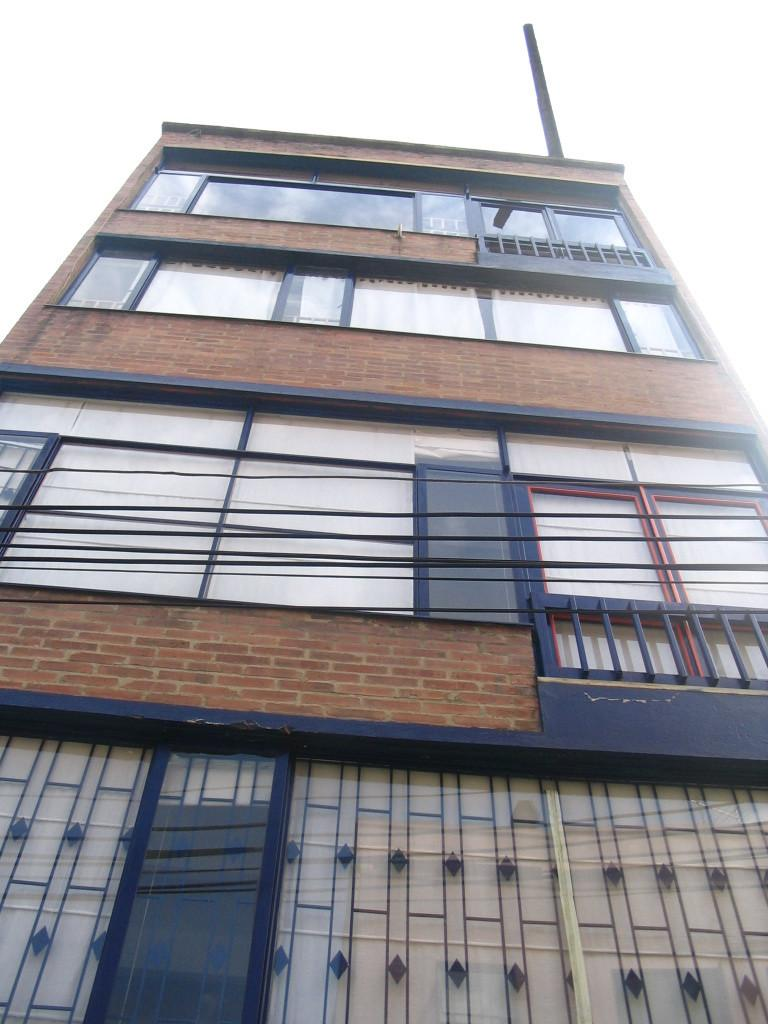What is the main structure in the image? There is a big building in the image. What material is used for some parts of the building? The building has glass elements, such as windows or walls. How much lettuce can be seen growing on the building in the image? There is no lettuce present on the building in the image. 